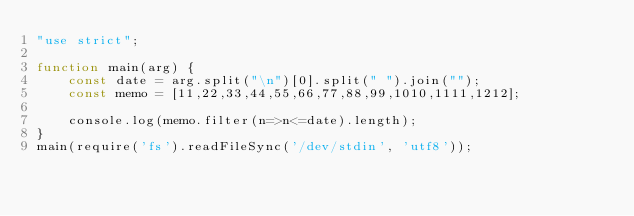Convert code to text. <code><loc_0><loc_0><loc_500><loc_500><_JavaScript_>"use strict";

function main(arg) {
    const date = arg.split("\n")[0].split(" ").join("");
    const memo = [11,22,33,44,55,66,77,88,99,1010,1111,1212];
    
    console.log(memo.filter(n=>n<=date).length);
}
main(require('fs').readFileSync('/dev/stdin', 'utf8'));</code> 